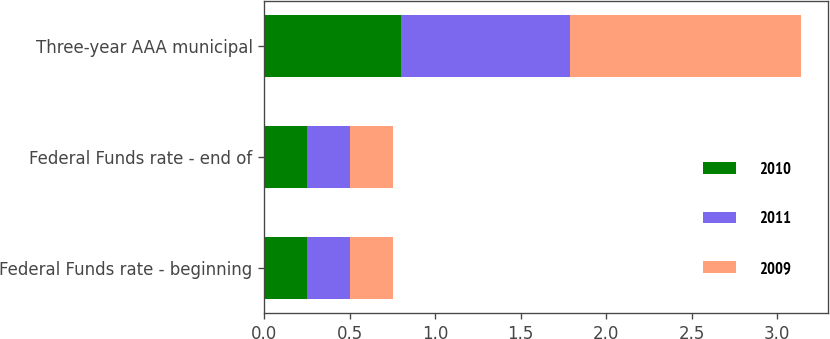Convert chart to OTSL. <chart><loc_0><loc_0><loc_500><loc_500><stacked_bar_chart><ecel><fcel>Federal Funds rate - beginning<fcel>Federal Funds rate - end of<fcel>Three-year AAA municipal<nl><fcel>2010<fcel>0.25<fcel>0.25<fcel>0.8<nl><fcel>2011<fcel>0.25<fcel>0.25<fcel>0.99<nl><fcel>2009<fcel>0.25<fcel>0.25<fcel>1.35<nl></chart> 